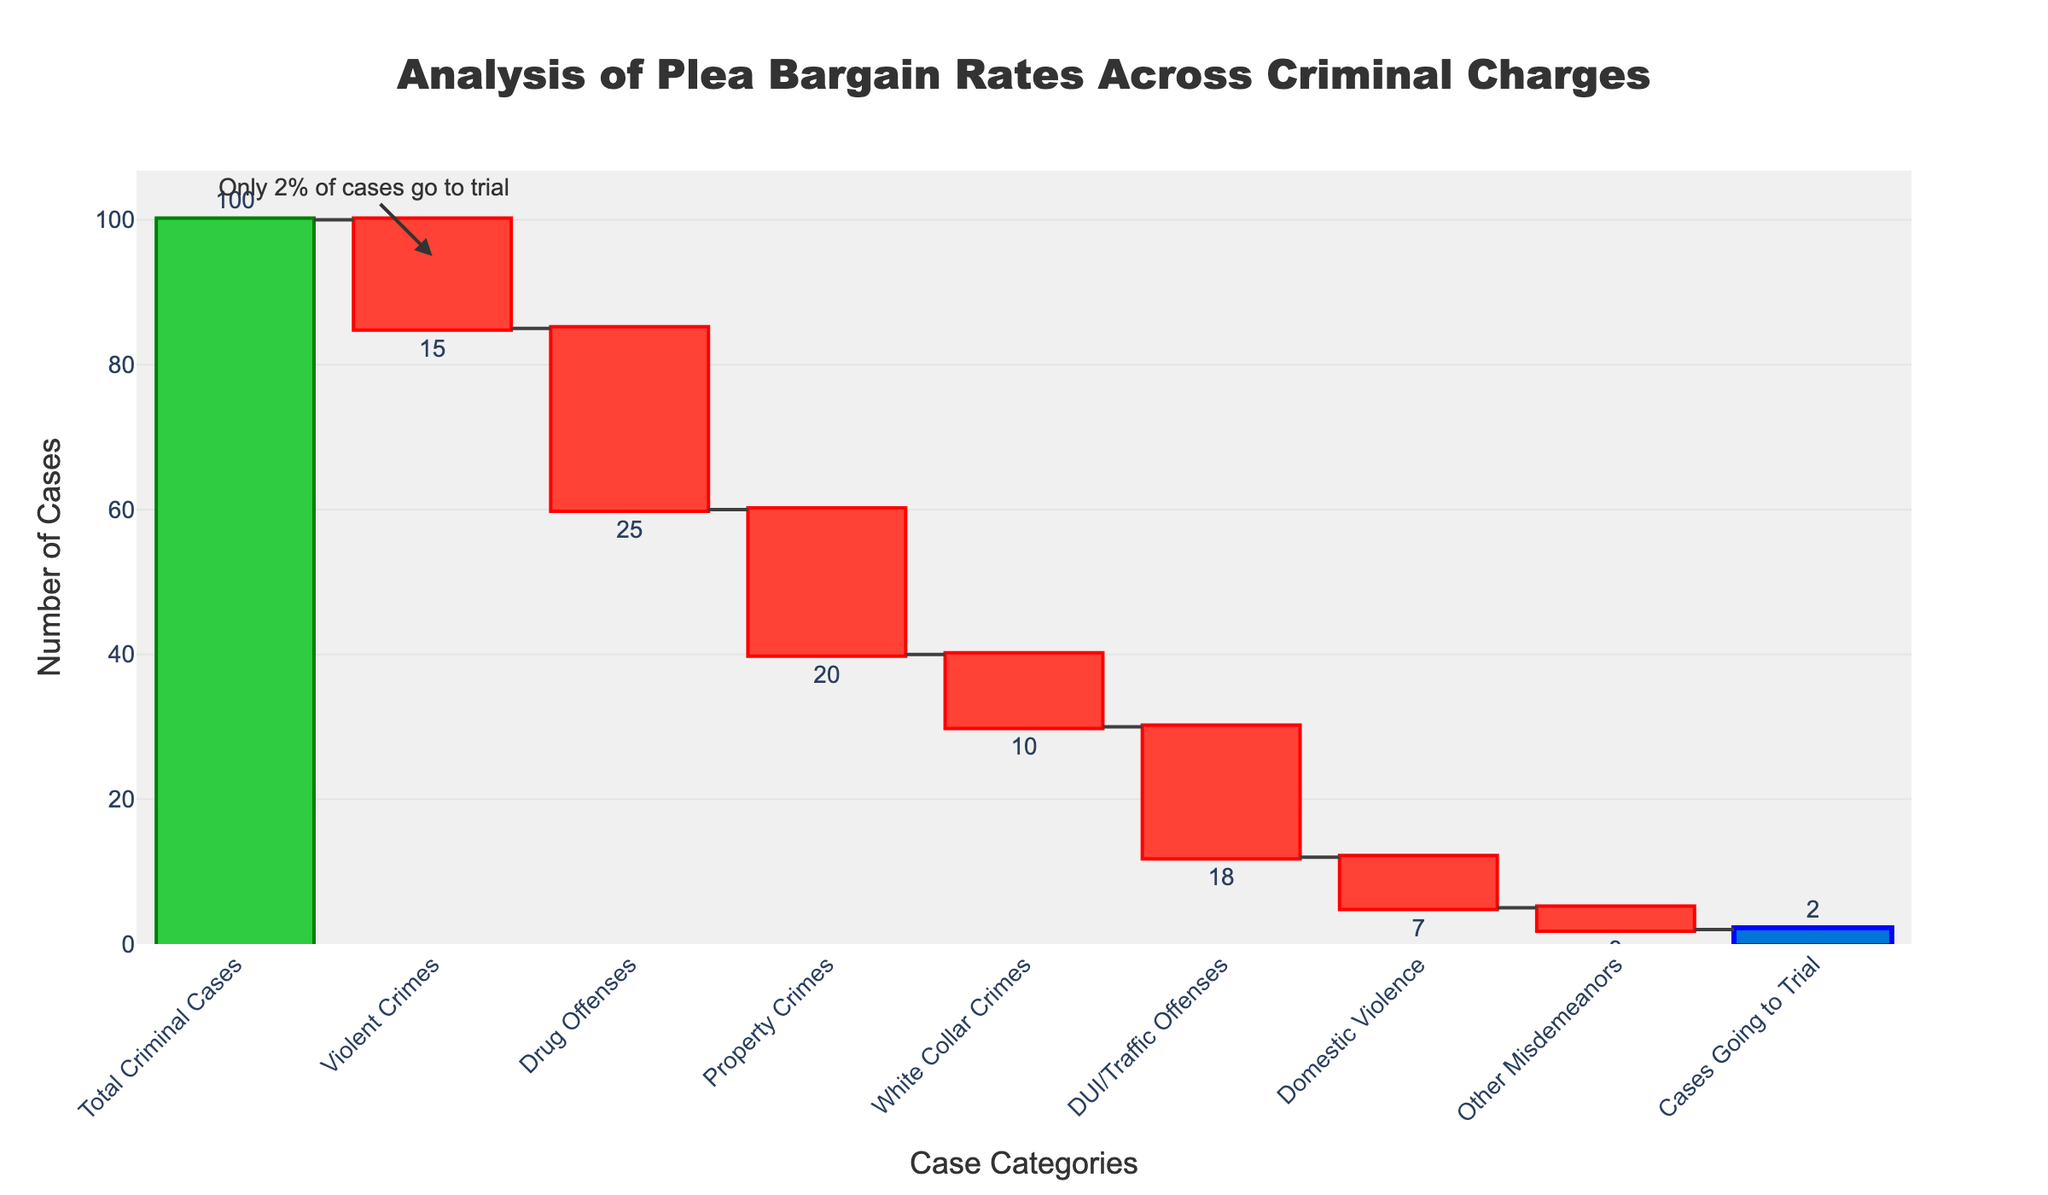What is the title of the chart? The title is located at the top center of the chart.
Answer: Analysis of Plea Bargain Rates Across Criminal Charges What color represents the total number of criminal cases? The total is represented by bars colored in blue, indicating it is different from other categories.
Answer: Blue How many cases are classified as "Drug Offenses"? Look at the bar labeled "Drug Offenses" and note the value attached to it.
Answer: 25 What do the green and red colors in the bars represent? Green indicates an increase, and red indicates a decrease in the number of cases compared to the previous category.
Answer: Green represents an increase, and red represents a decrease How many categories show a decrease in the number of cases? Each category represented by a red bar indicates a decrease. Count all red bars.
Answer: 7 Which category has the smallest contribution to the total number of cases? Identify the smallest bar (shortest in height) that has a negative value.
Answer: Other Misdemeanors What is the net change in the number of criminal cases after accounting for Domestic Violence charges? Subtract the value of Domestic Violence from the preceding total.
Answer: 100 - 15 - 25 - 20 - 10 - 18 - 7 = 5 (cumulative calculation excludes detailed breakdown) Which category has the highest reduction in the number of cases? Compare the magnitude of reduction (negative values) in the red bars for all categories.
Answer: Drug Offenses How does the annotation enhance the interpretation of the chart? The annotation provides specific insight or highlight about the final value in the visualization, making it easier to understand the context.
Answer: It emphasizes that only 2% of cases go to trial By what percentage did the number of DUI/Traffic Offenses cases decrease relative to the total number of criminal cases? Calculate the percentage decrease: (number of DUI/Traffic Offenses cases decreased / total number of criminal cases) * 100 = (18/100) * 100
Answer: 18% 